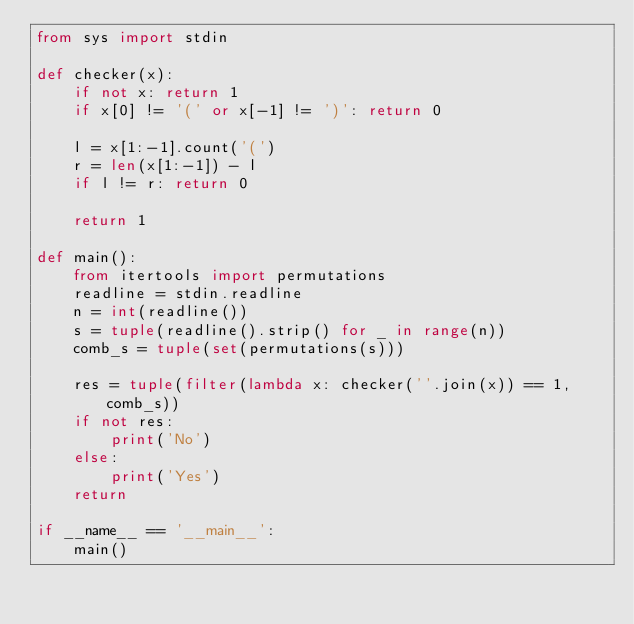Convert code to text. <code><loc_0><loc_0><loc_500><loc_500><_Python_>from sys import stdin

def checker(x):
    if not x: return 1
    if x[0] != '(' or x[-1] != ')': return 0

    l = x[1:-1].count('(')
    r = len(x[1:-1]) - l
    if l != r: return 0

    return 1

def main():
    from itertools import permutations
    readline = stdin.readline
    n = int(readline())
    s = tuple(readline().strip() for _ in range(n))
    comb_s = tuple(set(permutations(s)))

    res = tuple(filter(lambda x: checker(''.join(x)) == 1, comb_s))
    if not res:
        print('No')
    else:
        print('Yes')
    return

if __name__ == '__main__':
    main()
</code> 